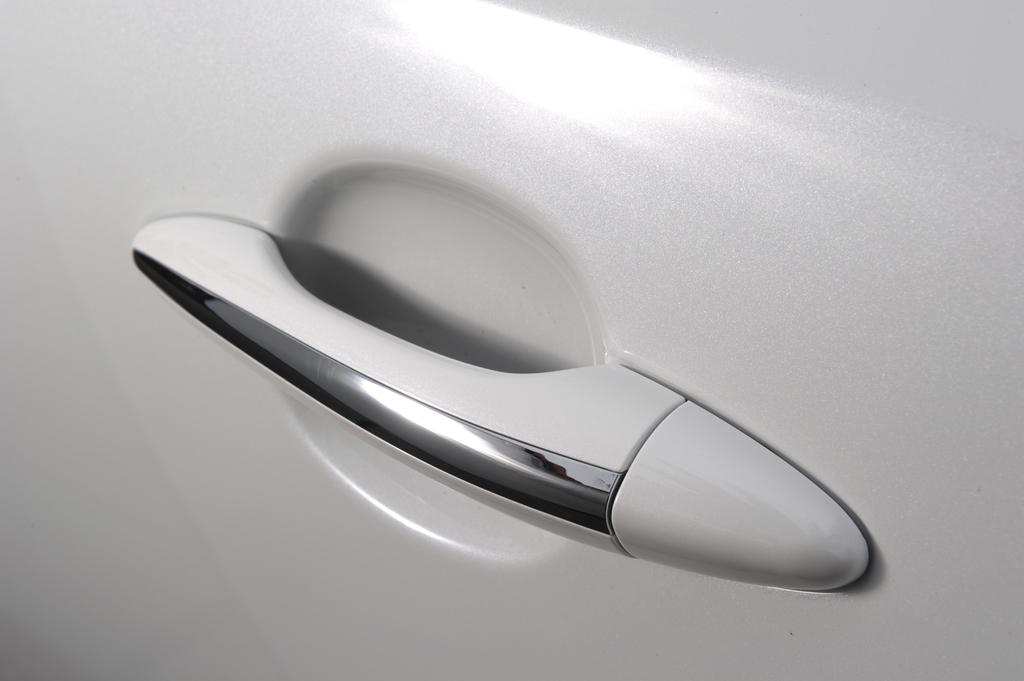What is the color of the car door in the image? The car door in the image is white. What part of the car door can be used to open or close it? The car door has a handle. What type of drink is being served on the tray in the image? There is no tray or drink present in the image; it only features a white car door with a handle. 